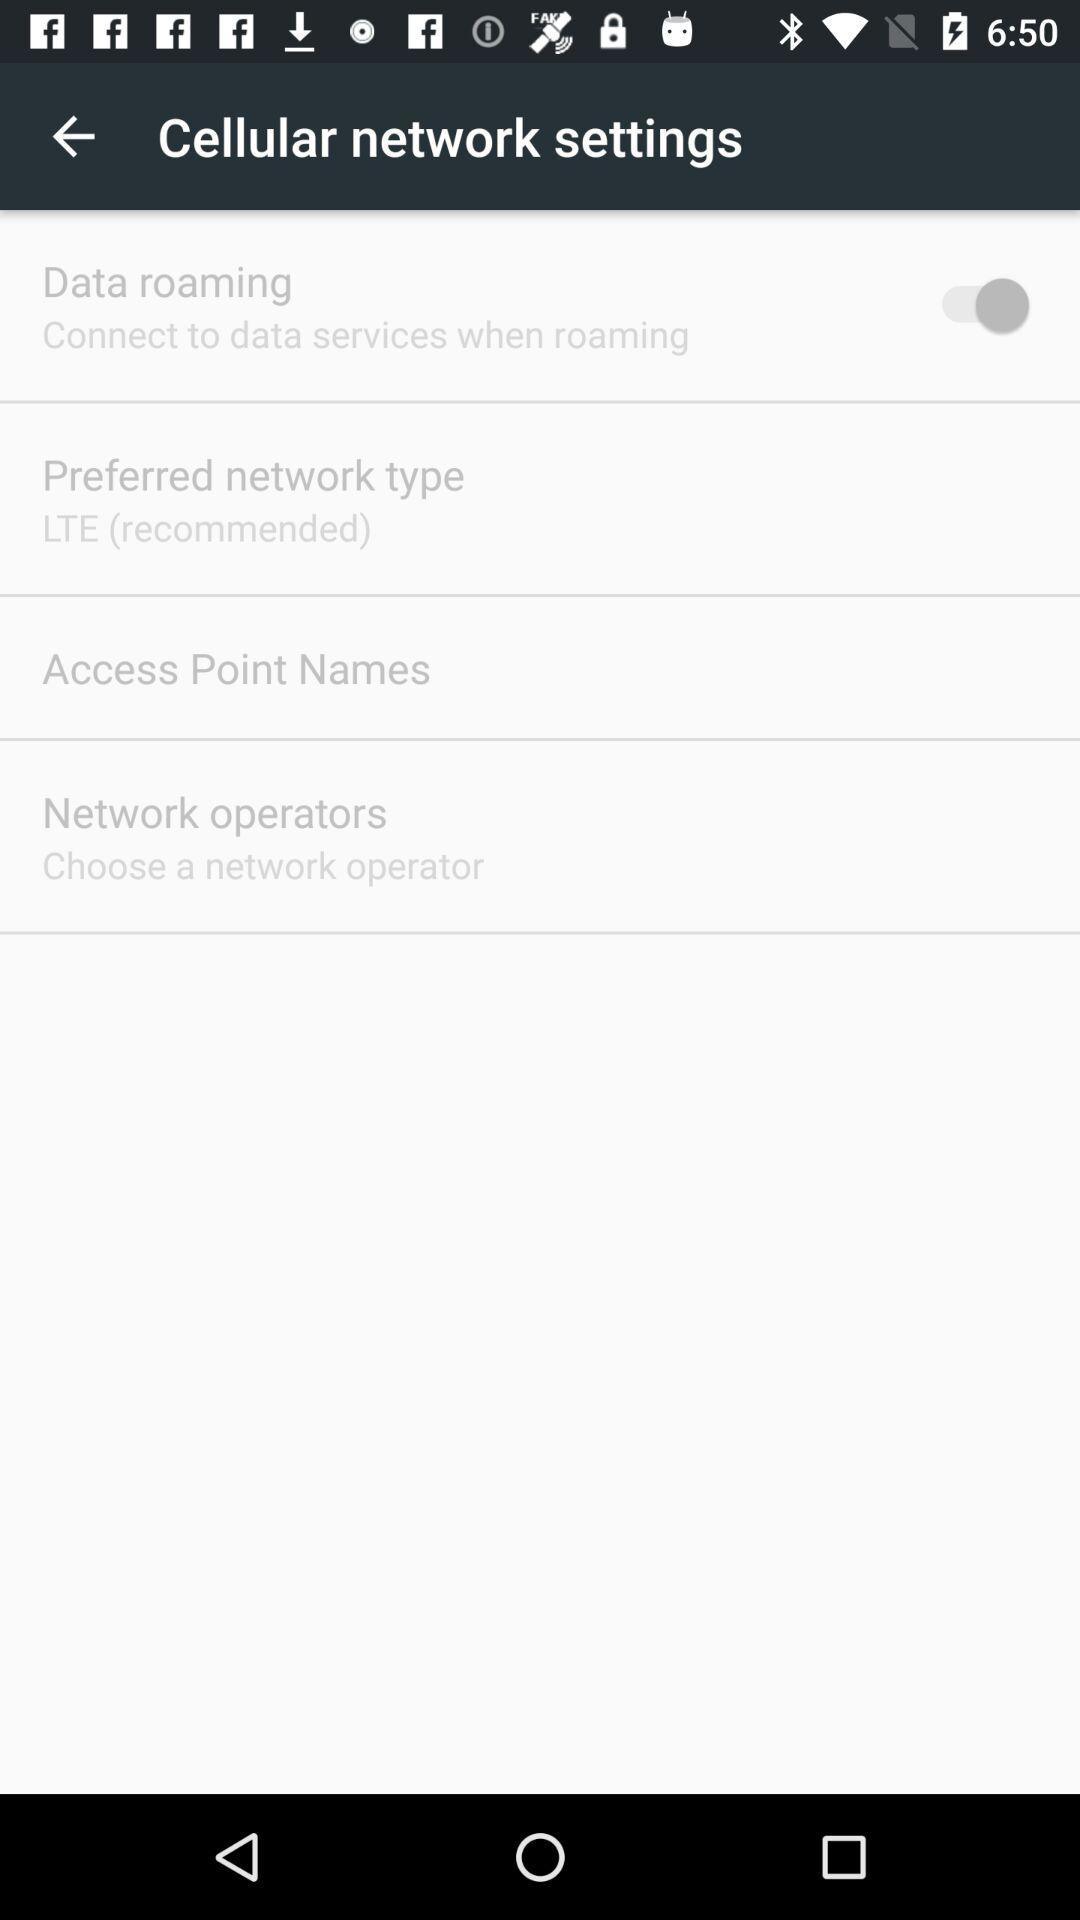What is the status of "Data roaming"? The status is "on". 